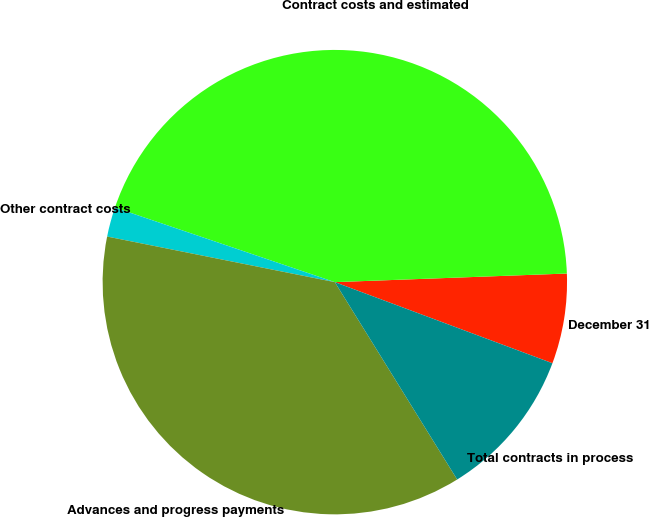<chart> <loc_0><loc_0><loc_500><loc_500><pie_chart><fcel>December 31<fcel>Contract costs and estimated<fcel>Other contract costs<fcel>Advances and progress payments<fcel>Total contracts in process<nl><fcel>6.27%<fcel>44.21%<fcel>2.06%<fcel>36.98%<fcel>10.49%<nl></chart> 